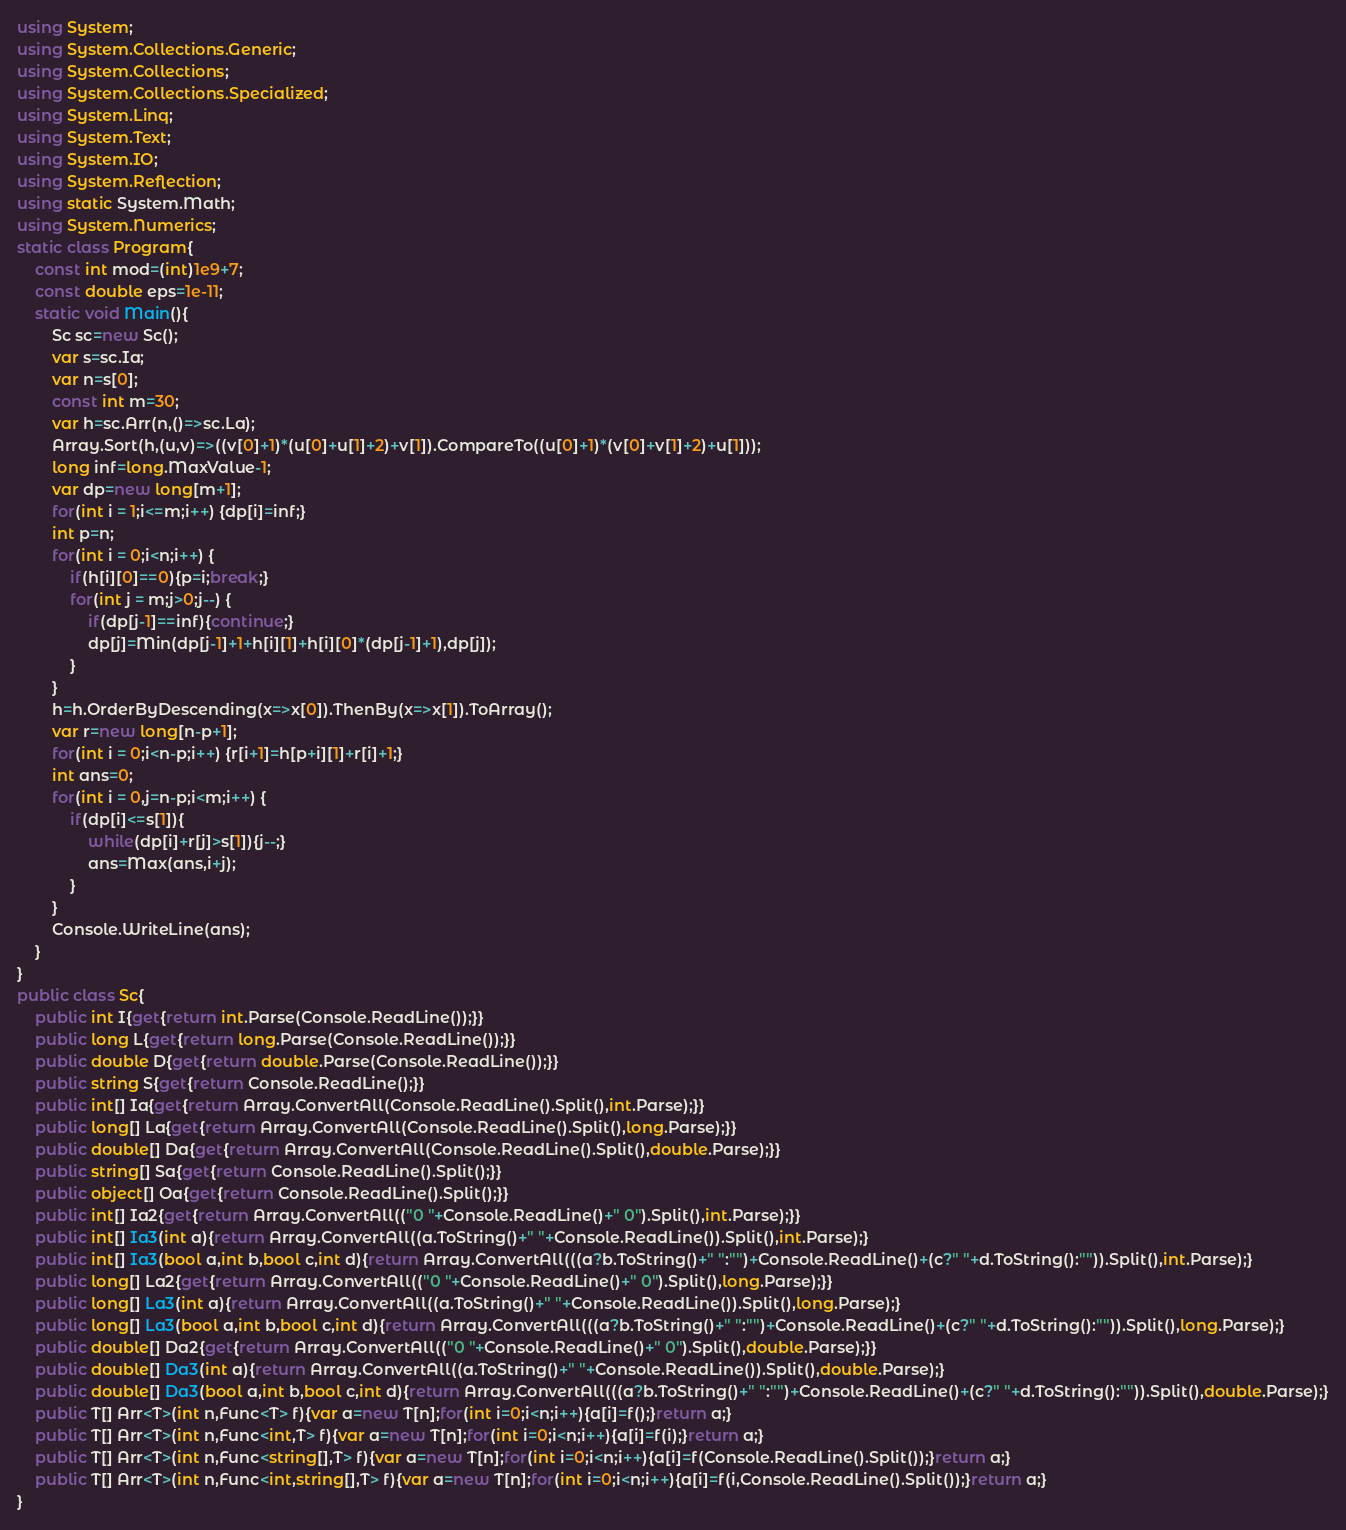Convert code to text. <code><loc_0><loc_0><loc_500><loc_500><_C#_>using System;
using System.Collections.Generic;
using System.Collections;
using System.Collections.Specialized;
using System.Linq;
using System.Text;
using System.IO;
using System.Reflection;
using static System.Math;
using System.Numerics;
static class Program{
	const int mod=(int)1e9+7;
	const double eps=1e-11;
	static void Main(){
		Sc sc=new Sc();
		var s=sc.Ia;
		var n=s[0];
		const int m=30;
		var h=sc.Arr(n,()=>sc.La);
		Array.Sort(h,(u,v)=>((v[0]+1)*(u[0]+u[1]+2)+v[1]).CompareTo((u[0]+1)*(v[0]+v[1]+2)+u[1]));
		long inf=long.MaxValue-1;
		var dp=new long[m+1];
		for(int i = 1;i<=m;i++) {dp[i]=inf;}
		int p=n;
		for(int i = 0;i<n;i++) {
			if(h[i][0]==0){p=i;break;}
			for(int j = m;j>0;j--) {
				if(dp[j-1]==inf){continue;}
				dp[j]=Min(dp[j-1]+1+h[i][1]+h[i][0]*(dp[j-1]+1),dp[j]);
			}
		}
		h=h.OrderByDescending(x=>x[0]).ThenBy(x=>x[1]).ToArray();
		var r=new long[n-p+1];
		for(int i = 0;i<n-p;i++) {r[i+1]=h[p+i][1]+r[i]+1;}
		int ans=0;
		for(int i = 0,j=n-p;i<m;i++) {
			if(dp[i]<=s[1]){
				while(dp[i]+r[j]>s[1]){j--;}
				ans=Max(ans,i+j);
			}
		}
		Console.WriteLine(ans);
	}
}
public class Sc{
	public int I{get{return int.Parse(Console.ReadLine());}}
	public long L{get{return long.Parse(Console.ReadLine());}}
	public double D{get{return double.Parse(Console.ReadLine());}}
	public string S{get{return Console.ReadLine();}}
	public int[] Ia{get{return Array.ConvertAll(Console.ReadLine().Split(),int.Parse);}}
	public long[] La{get{return Array.ConvertAll(Console.ReadLine().Split(),long.Parse);}}
	public double[] Da{get{return Array.ConvertAll(Console.ReadLine().Split(),double.Parse);}}
	public string[] Sa{get{return Console.ReadLine().Split();}}
	public object[] Oa{get{return Console.ReadLine().Split();}}
	public int[] Ia2{get{return Array.ConvertAll(("0 "+Console.ReadLine()+" 0").Split(),int.Parse);}}
	public int[] Ia3(int a){return Array.ConvertAll((a.ToString()+" "+Console.ReadLine()).Split(),int.Parse);}
	public int[] Ia3(bool a,int b,bool c,int d){return Array.ConvertAll(((a?b.ToString()+" ":"")+Console.ReadLine()+(c?" "+d.ToString():"")).Split(),int.Parse);}
	public long[] La2{get{return Array.ConvertAll(("0 "+Console.ReadLine()+" 0").Split(),long.Parse);}}
	public long[] La3(int a){return Array.ConvertAll((a.ToString()+" "+Console.ReadLine()).Split(),long.Parse);}
	public long[] La3(bool a,int b,bool c,int d){return Array.ConvertAll(((a?b.ToString()+" ":"")+Console.ReadLine()+(c?" "+d.ToString():"")).Split(),long.Parse);}
	public double[] Da2{get{return Array.ConvertAll(("0 "+Console.ReadLine()+" 0").Split(),double.Parse);}}
	public double[] Da3(int a){return Array.ConvertAll((a.ToString()+" "+Console.ReadLine()).Split(),double.Parse);}
	public double[] Da3(bool a,int b,bool c,int d){return Array.ConvertAll(((a?b.ToString()+" ":"")+Console.ReadLine()+(c?" "+d.ToString():"")).Split(),double.Parse);}
	public T[] Arr<T>(int n,Func<T> f){var a=new T[n];for(int i=0;i<n;i++){a[i]=f();}return a;}
	public T[] Arr<T>(int n,Func<int,T> f){var a=new T[n];for(int i=0;i<n;i++){a[i]=f(i);}return a;}
	public T[] Arr<T>(int n,Func<string[],T> f){var a=new T[n];for(int i=0;i<n;i++){a[i]=f(Console.ReadLine().Split());}return a;}
	public T[] Arr<T>(int n,Func<int,string[],T> f){var a=new T[n];for(int i=0;i<n;i++){a[i]=f(i,Console.ReadLine().Split());}return a;}
}
</code> 